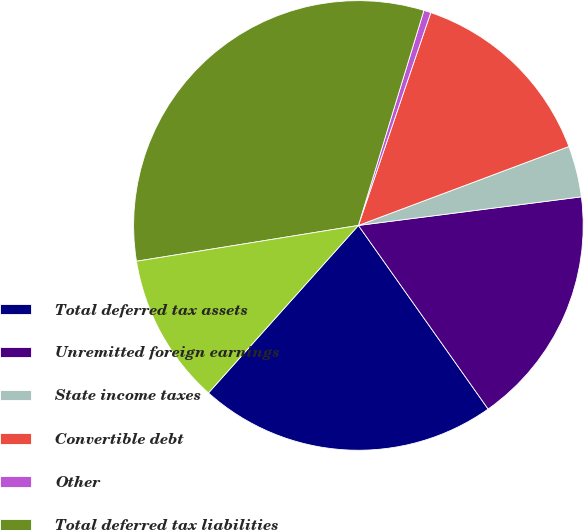<chart> <loc_0><loc_0><loc_500><loc_500><pie_chart><fcel>Total deferred tax assets<fcel>Unremitted foreign earnings<fcel>State income taxes<fcel>Convertible debt<fcel>Other<fcel>Total deferred tax liabilities<fcel>Total net deferred tax<nl><fcel>21.41%<fcel>17.24%<fcel>3.68%<fcel>14.07%<fcel>0.51%<fcel>32.25%<fcel>10.83%<nl></chart> 